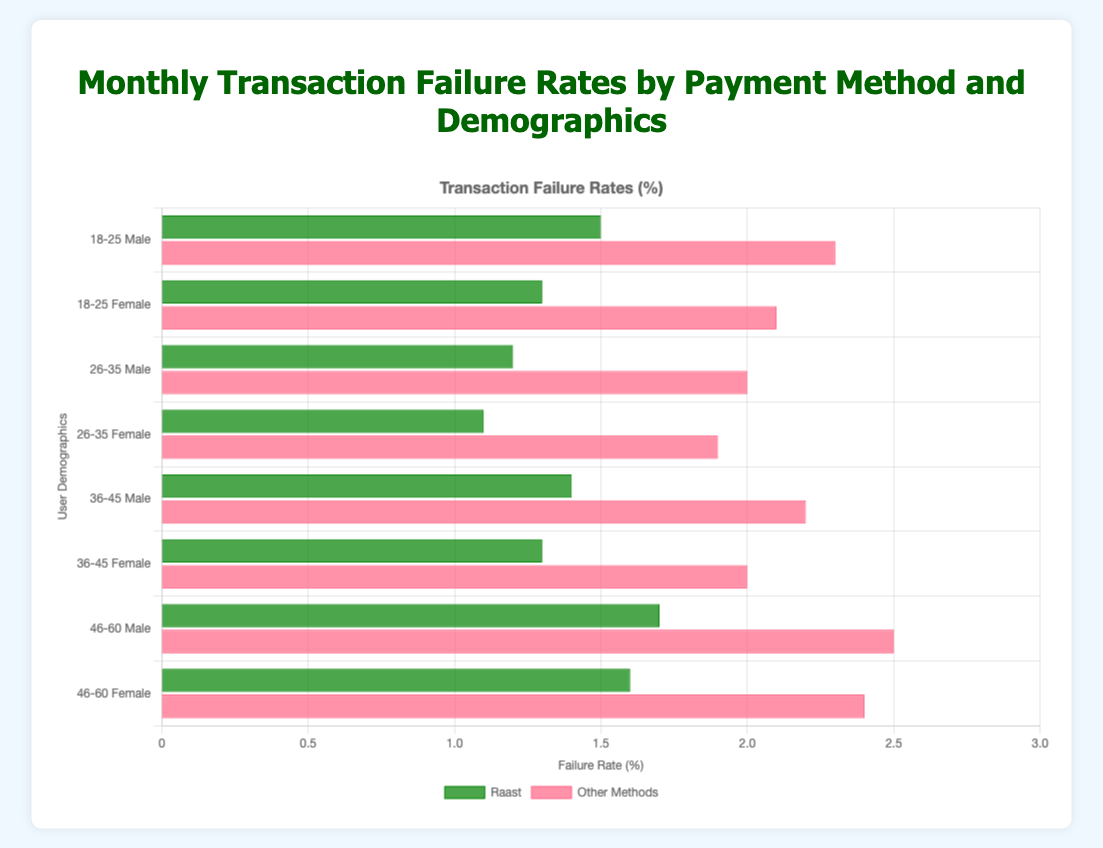Which payment method has the highest transaction failure rate for the 46-60 Male demographic? The 46-60 Male demographic has failure rates of 1.7% for Raast and 2.5% for Other Methods. Comparing these, Other Methods have the higher rate.
Answer: Other Methods Which demographic has the lowest transaction failure rate for Raast? Looking at the Raast failure rates, the 26-35 Female demographic has the lowest rate at 1.1%.
Answer: 26-35 Female What is the average transaction failure rate for Raast across all demographics? Summing up all failure rates for Raast (1.5 + 1.3 + 1.2 + 1.1 + 1.4 + 1.3 + 1.7 + 1.6 = 11.1) and dividing by the number of demographics (8), the average is 11.1 / 8 = 1.3875.
Answer: 1.39% By how much do transaction failure rates for Other Methods exceed those for Raast in the 18-25 Female demographic? The failure rate for Other Methods in the 18-25 Female demographic is 2.1%, and for Raast, it is 1.3%. The difference is 2.1 - 1.3 = 0.8.
Answer: 0.8% Which demographic shows the smallest difference in failure rates between Raast and Other Methods? Calculating the differences for each demographic: 
18-25 Male: 2.3 - 1.5 = 0.8 
18-25 Female: 2.1 - 1.3 = 0.8 
26-35 Male: 2.0 - 1.2 = 0.8 
26-35 Female: 1.9 - 1.1 = 0.8 
36-45 Male: 2.2 - 1.4 = 0.8 
36-45 Female: 2.0 - 1.3 = 0.7 
46-60 Male: 2.5 - 1.7 = 0.8 
46-60 Female: 2.4 - 1.6 = 0.8 
The smallest difference is for the 36-45 Female demographic with a difference of 0.7.
Answer: 36-45 Female What is the total transaction failure rate for Other Methods for the 26-45 age group? Summing the failure rates for 26-35 Male (2.0), 26-35 Female (1.9), 36-45 Male (2.2), and 36-45 Female (2.0): 2.0 + 1.9 + 2.2 + 2.0 = 8.1.
Answer: 8.1% Which age group has the highest average transaction failure rate for Raast? Calculating the average failure rate for each age group:
18-25: (1.5 + 1.3) / 2 = 1.4
26-35: (1.2 + 1.1) / 2 = 1.15
36-45: (1.4 + 1.3) / 2 = 1.35
46-60: (1.7 + 1.6) / 2 = 1.65
The highest average transaction failure rate is for the 46-60 age group with 1.65%.
Answer: 46-60 